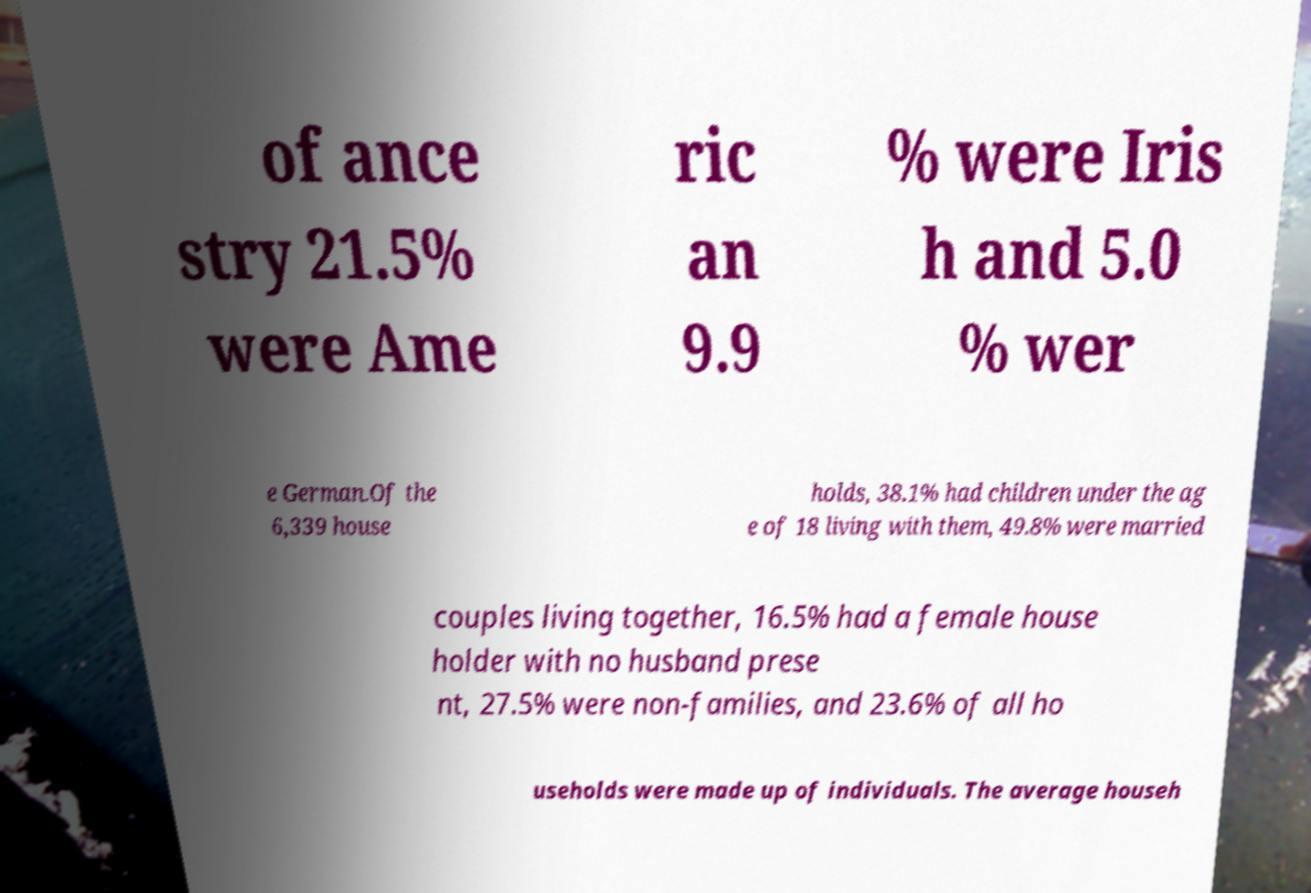Please read and relay the text visible in this image. What does it say? of ance stry 21.5% were Ame ric an 9.9 % were Iris h and 5.0 % wer e German.Of the 6,339 house holds, 38.1% had children under the ag e of 18 living with them, 49.8% were married couples living together, 16.5% had a female house holder with no husband prese nt, 27.5% were non-families, and 23.6% of all ho useholds were made up of individuals. The average househ 